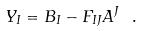Convert formula to latex. <formula><loc_0><loc_0><loc_500><loc_500>Y _ { I } = B _ { I } - F _ { I J } A ^ { J } \ .</formula> 